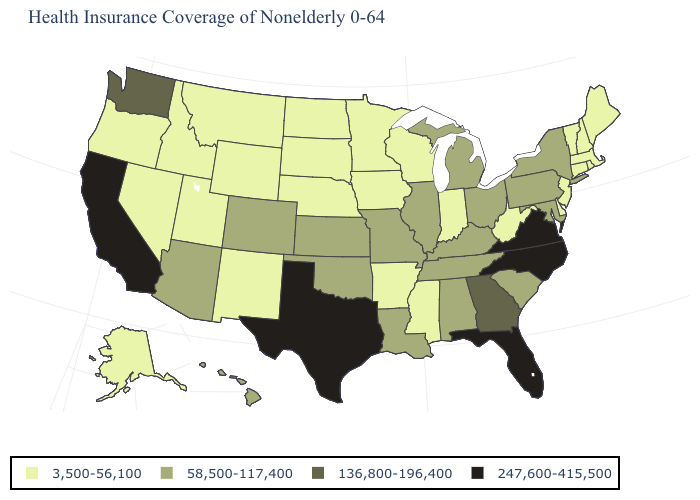Does Ohio have the highest value in the MidWest?
Answer briefly. Yes. Does North Dakota have the lowest value in the MidWest?
Give a very brief answer. Yes. What is the value of Utah?
Answer briefly. 3,500-56,100. Among the states that border Mississippi , does Tennessee have the lowest value?
Short answer required. No. What is the highest value in states that border Nebraska?
Short answer required. 58,500-117,400. Among the states that border Kansas , does Nebraska have the highest value?
Be succinct. No. Name the states that have a value in the range 58,500-117,400?
Keep it brief. Alabama, Arizona, Colorado, Hawaii, Illinois, Kansas, Kentucky, Louisiana, Maryland, Michigan, Missouri, New York, Ohio, Oklahoma, Pennsylvania, South Carolina, Tennessee. What is the value of New Jersey?
Answer briefly. 3,500-56,100. How many symbols are there in the legend?
Give a very brief answer. 4. Does the map have missing data?
Concise answer only. No. Name the states that have a value in the range 136,800-196,400?
Be succinct. Georgia, Washington. What is the value of New York?
Give a very brief answer. 58,500-117,400. What is the lowest value in the USA?
Answer briefly. 3,500-56,100. What is the lowest value in the South?
Be succinct. 3,500-56,100. Name the states that have a value in the range 136,800-196,400?
Write a very short answer. Georgia, Washington. 